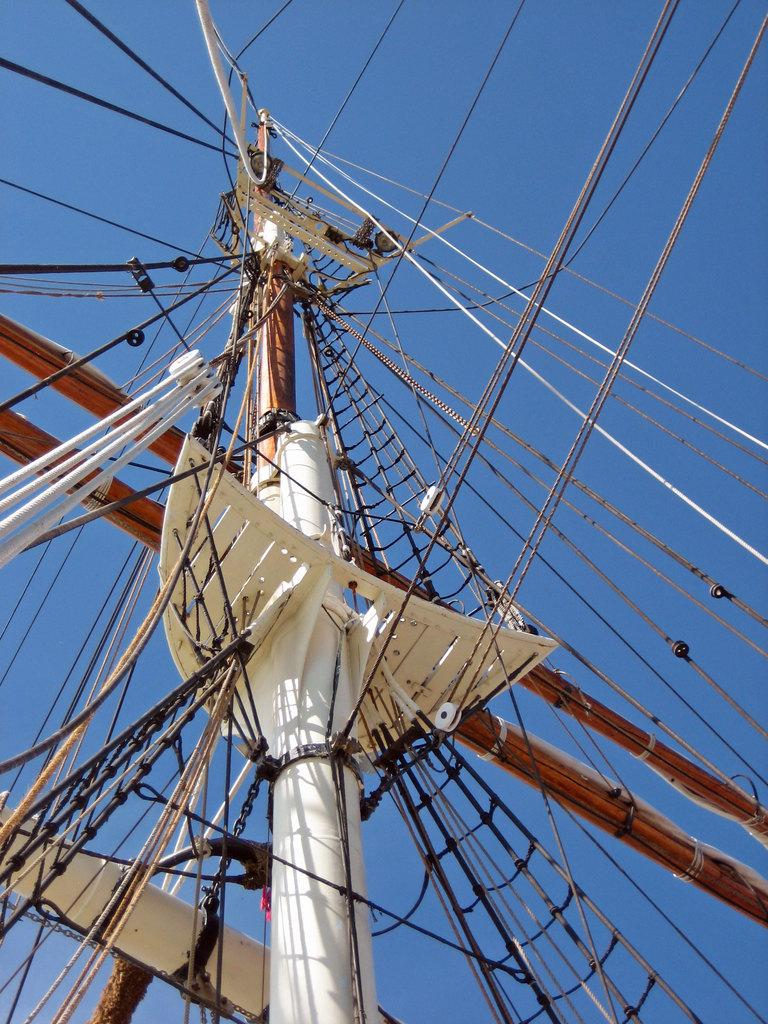What is the main object in the image? There is a pole in the image. What is connected to the pole? Wires and ropes are attached to the pole. What can be seen in the background of the image? The sky is visible behind the pole. What type of copy machine is visible near the pole in the image? There is no copy machine present in the image; it only features a pole with wires and ropes attached, and the sky in the background. 